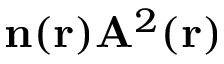<formula> <loc_0><loc_0><loc_500><loc_500>n ( r ) A ^ { 2 } ( r )</formula> 